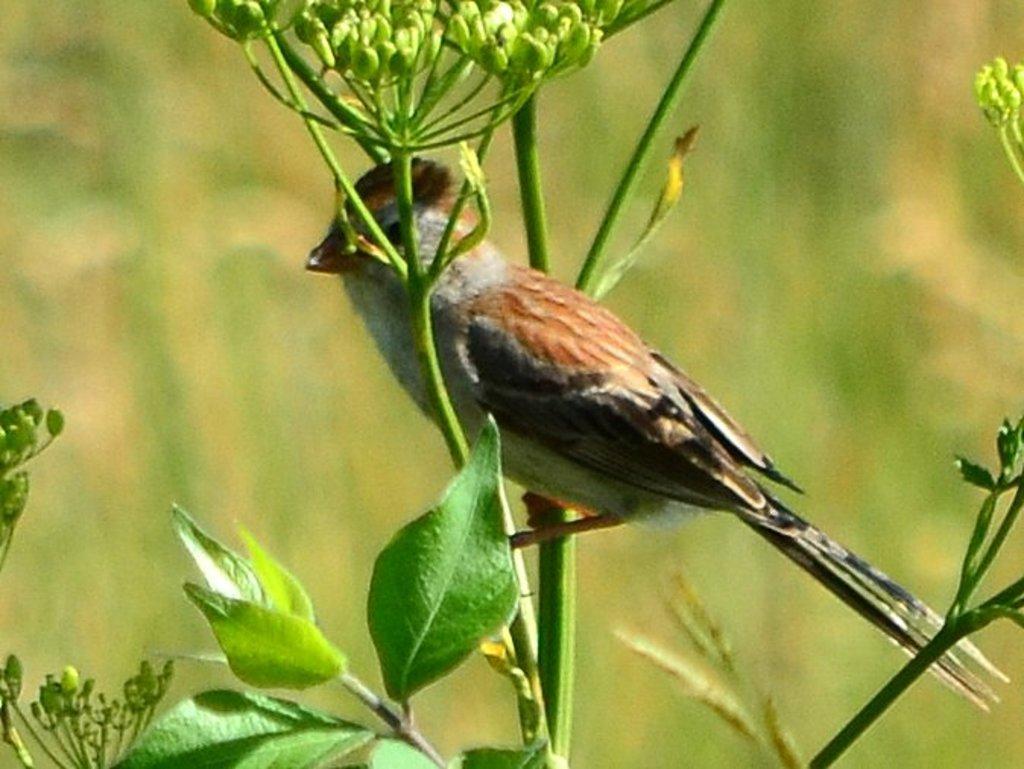Can you describe this image briefly? In this image there is a bird standing on the stem of a plant. The plant is having few leaves and flower buds. 